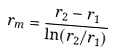<formula> <loc_0><loc_0><loc_500><loc_500>r _ { m } = \frac { r _ { 2 } - r _ { 1 } } { \ln ( r _ { 2 } / r _ { 1 } ) }</formula> 